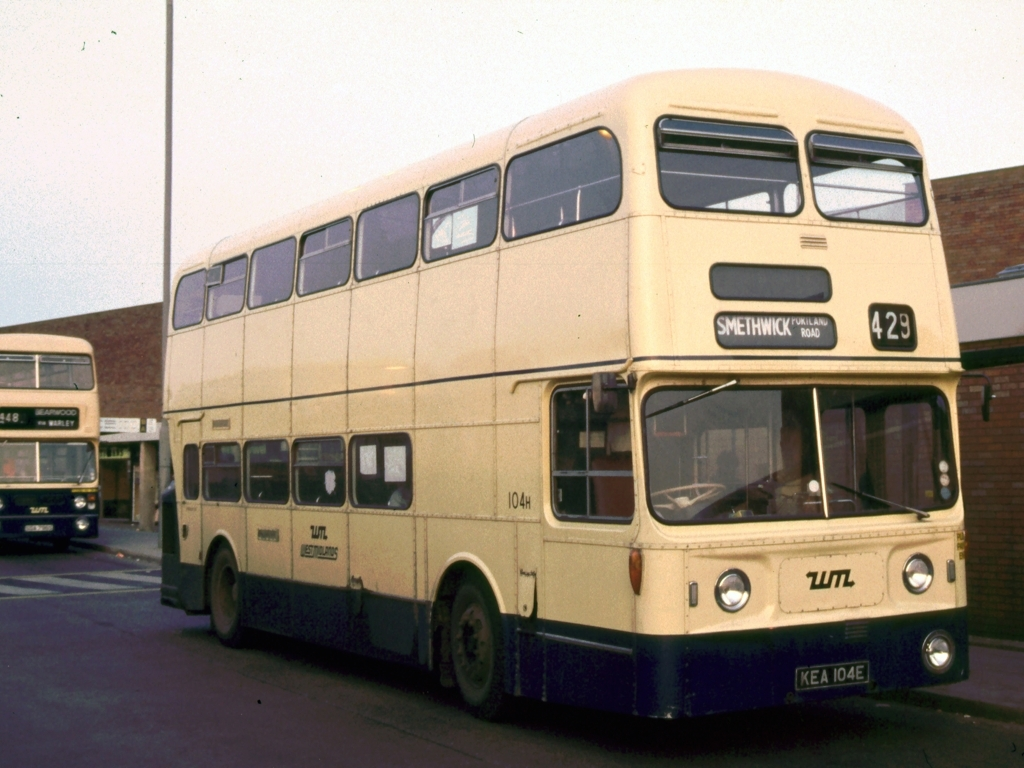Can you tell me more about the route number mentioned on the bus? The route number displayed on the bus is 429, which indicates the service number the bus is operating on. Route numbers are assigned to bus services to designate their particular paths and stopping points, often connecting various towns, districts, or city areas. 